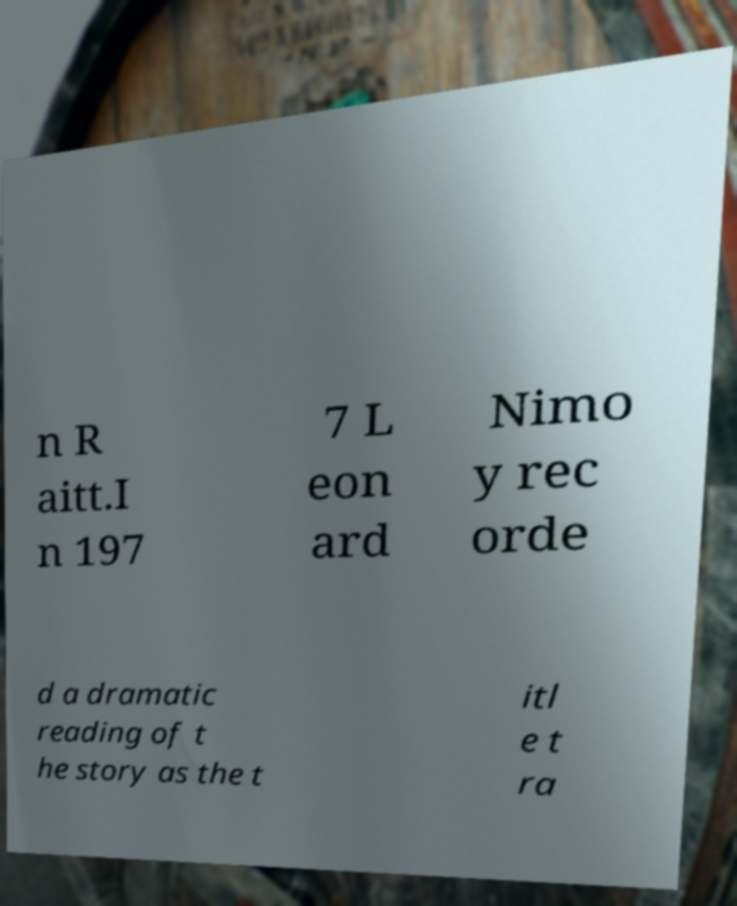What messages or text are displayed in this image? I need them in a readable, typed format. n R aitt.I n 197 7 L eon ard Nimo y rec orde d a dramatic reading of t he story as the t itl e t ra 